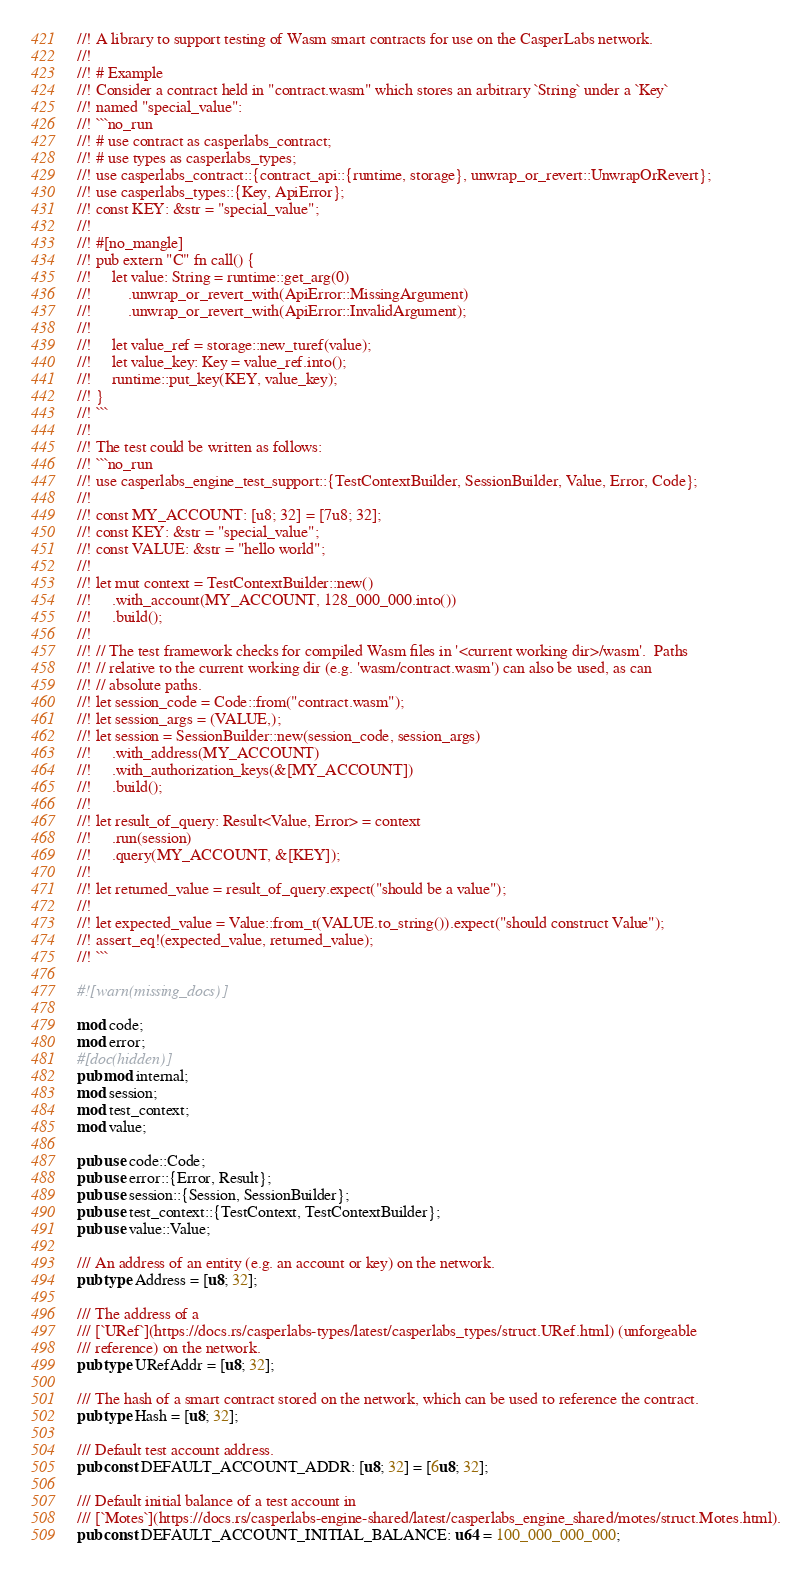Convert code to text. <code><loc_0><loc_0><loc_500><loc_500><_Rust_>//! A library to support testing of Wasm smart contracts for use on the CasperLabs network.
//!
//! # Example
//! Consider a contract held in "contract.wasm" which stores an arbitrary `String` under a `Key`
//! named "special_value":
//! ```no_run
//! # use contract as casperlabs_contract;
//! # use types as casperlabs_types;
//! use casperlabs_contract::{contract_api::{runtime, storage}, unwrap_or_revert::UnwrapOrRevert};
//! use casperlabs_types::{Key, ApiError};
//! const KEY: &str = "special_value";
//!
//! #[no_mangle]
//! pub extern "C" fn call() {
//!     let value: String = runtime::get_arg(0)
//!         .unwrap_or_revert_with(ApiError::MissingArgument)
//!         .unwrap_or_revert_with(ApiError::InvalidArgument);
//!
//!     let value_ref = storage::new_turef(value);
//!     let value_key: Key = value_ref.into();
//!     runtime::put_key(KEY, value_key);
//! }
//! ```
//!
//! The test could be written as follows:
//! ```no_run
//! use casperlabs_engine_test_support::{TestContextBuilder, SessionBuilder, Value, Error, Code};
//!
//! const MY_ACCOUNT: [u8; 32] = [7u8; 32];
//! const KEY: &str = "special_value";
//! const VALUE: &str = "hello world";
//!
//! let mut context = TestContextBuilder::new()
//!     .with_account(MY_ACCOUNT, 128_000_000.into())
//!     .build();
//!
//! // The test framework checks for compiled Wasm files in '<current working dir>/wasm'.  Paths
//! // relative to the current working dir (e.g. 'wasm/contract.wasm') can also be used, as can
//! // absolute paths.
//! let session_code = Code::from("contract.wasm");
//! let session_args = (VALUE,);
//! let session = SessionBuilder::new(session_code, session_args)
//!     .with_address(MY_ACCOUNT)
//!     .with_authorization_keys(&[MY_ACCOUNT])
//!     .build();
//!
//! let result_of_query: Result<Value, Error> = context
//!     .run(session)
//!     .query(MY_ACCOUNT, &[KEY]);
//!
//! let returned_value = result_of_query.expect("should be a value");
//!
//! let expected_value = Value::from_t(VALUE.to_string()).expect("should construct Value");
//! assert_eq!(expected_value, returned_value);
//! ```

#![warn(missing_docs)]

mod code;
mod error;
#[doc(hidden)]
pub mod internal;
mod session;
mod test_context;
mod value;

pub use code::Code;
pub use error::{Error, Result};
pub use session::{Session, SessionBuilder};
pub use test_context::{TestContext, TestContextBuilder};
pub use value::Value;

/// An address of an entity (e.g. an account or key) on the network.
pub type Address = [u8; 32];

/// The address of a
/// [`URef`](https://docs.rs/casperlabs-types/latest/casperlabs_types/struct.URef.html) (unforgeable
/// reference) on the network.
pub type URefAddr = [u8; 32];

/// The hash of a smart contract stored on the network, which can be used to reference the contract.
pub type Hash = [u8; 32];

/// Default test account address.
pub const DEFAULT_ACCOUNT_ADDR: [u8; 32] = [6u8; 32];

/// Default initial balance of a test account in
/// [`Motes`](https://docs.rs/casperlabs-engine-shared/latest/casperlabs_engine_shared/motes/struct.Motes.html).
pub const DEFAULT_ACCOUNT_INITIAL_BALANCE: u64 = 100_000_000_000;
</code> 